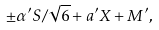<formula> <loc_0><loc_0><loc_500><loc_500>\pm \alpha ^ { \prime } S / \sqrt { 6 } + a ^ { \prime } X + M ^ { \prime } ,</formula> 